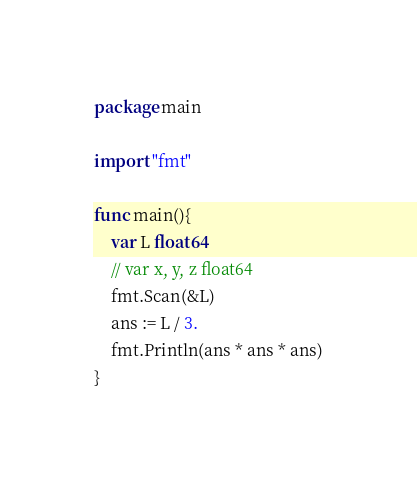<code> <loc_0><loc_0><loc_500><loc_500><_Go_>package main

import "fmt"

func main(){
	var L float64
	// var x, y, z float64
	fmt.Scan(&L)
	ans := L / 3.
	fmt.Println(ans * ans * ans)
}</code> 